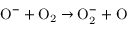Convert formula to latex. <formula><loc_0><loc_0><loc_500><loc_500>O ^ { - } + O _ { 2 } \to O _ { 2 } ^ { - } + O</formula> 